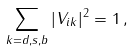<formula> <loc_0><loc_0><loc_500><loc_500>\sum _ { k = d , s , b } | V _ { i k } | ^ { 2 } = 1 \, ,</formula> 